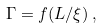<formula> <loc_0><loc_0><loc_500><loc_500>\Gamma = f ( L / \xi ) \, ,</formula> 